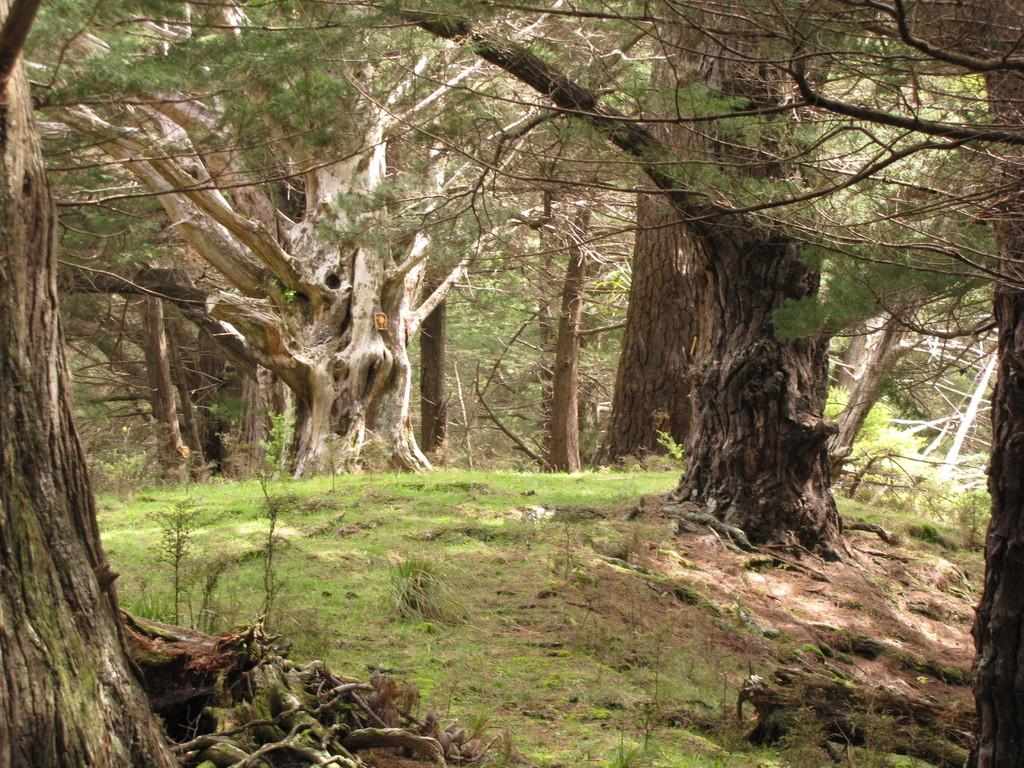What type of vegetation can be seen in the image? There are green color trees in the image. What is the color of the grass in the image? There is green grass in the image. Is there a maid in the image who is sharing her experience of blowing bubbles? There is no maid or bubbles present in the image; it only features green trees and grass. 